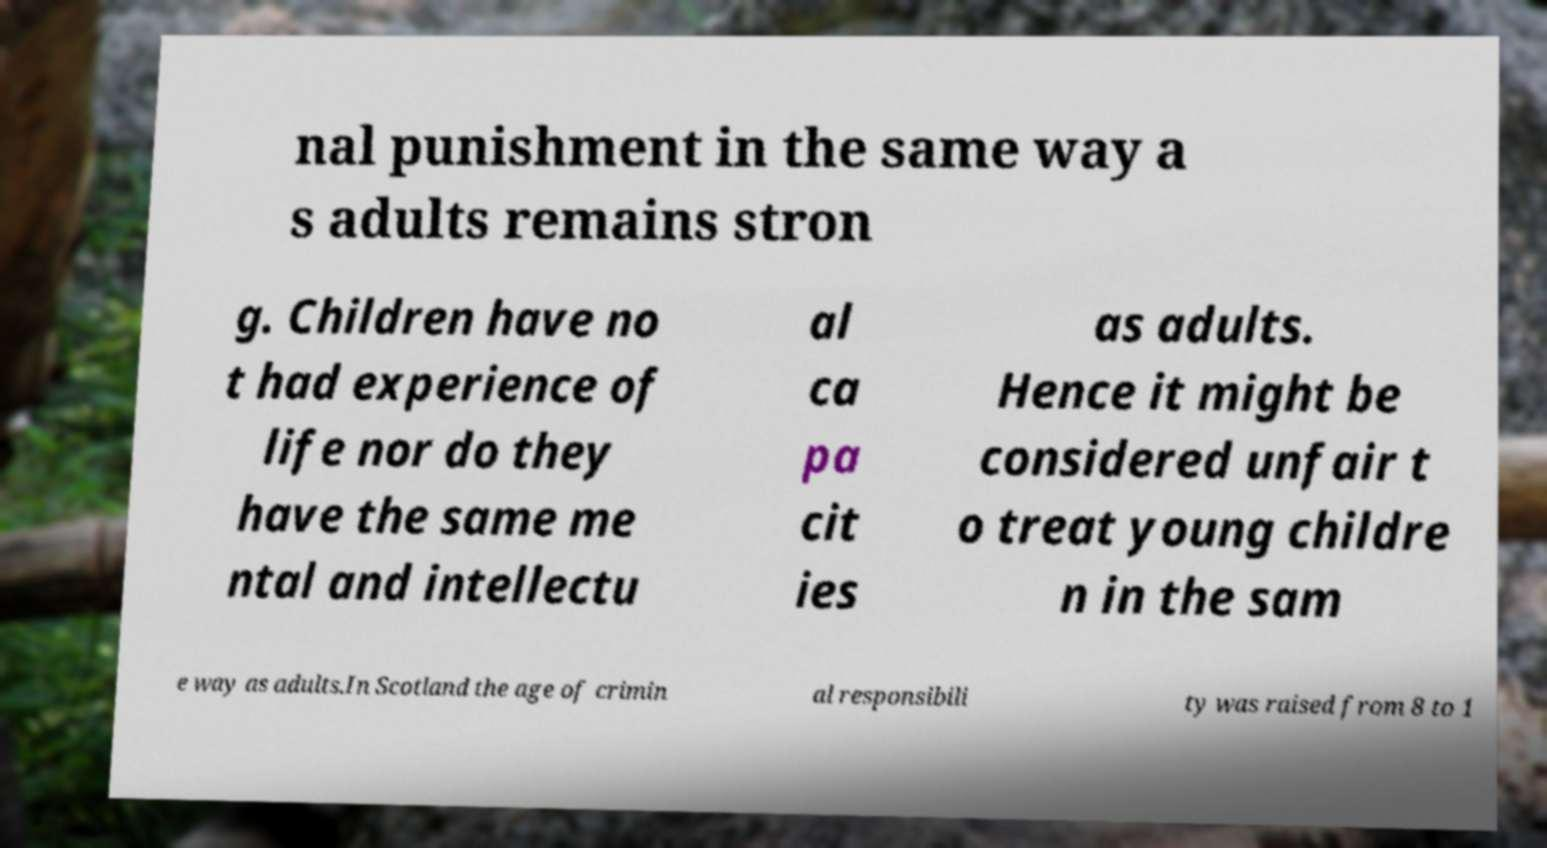Please read and relay the text visible in this image. What does it say? nal punishment in the same way a s adults remains stron g. Children have no t had experience of life nor do they have the same me ntal and intellectu al ca pa cit ies as adults. Hence it might be considered unfair t o treat young childre n in the sam e way as adults.In Scotland the age of crimin al responsibili ty was raised from 8 to 1 